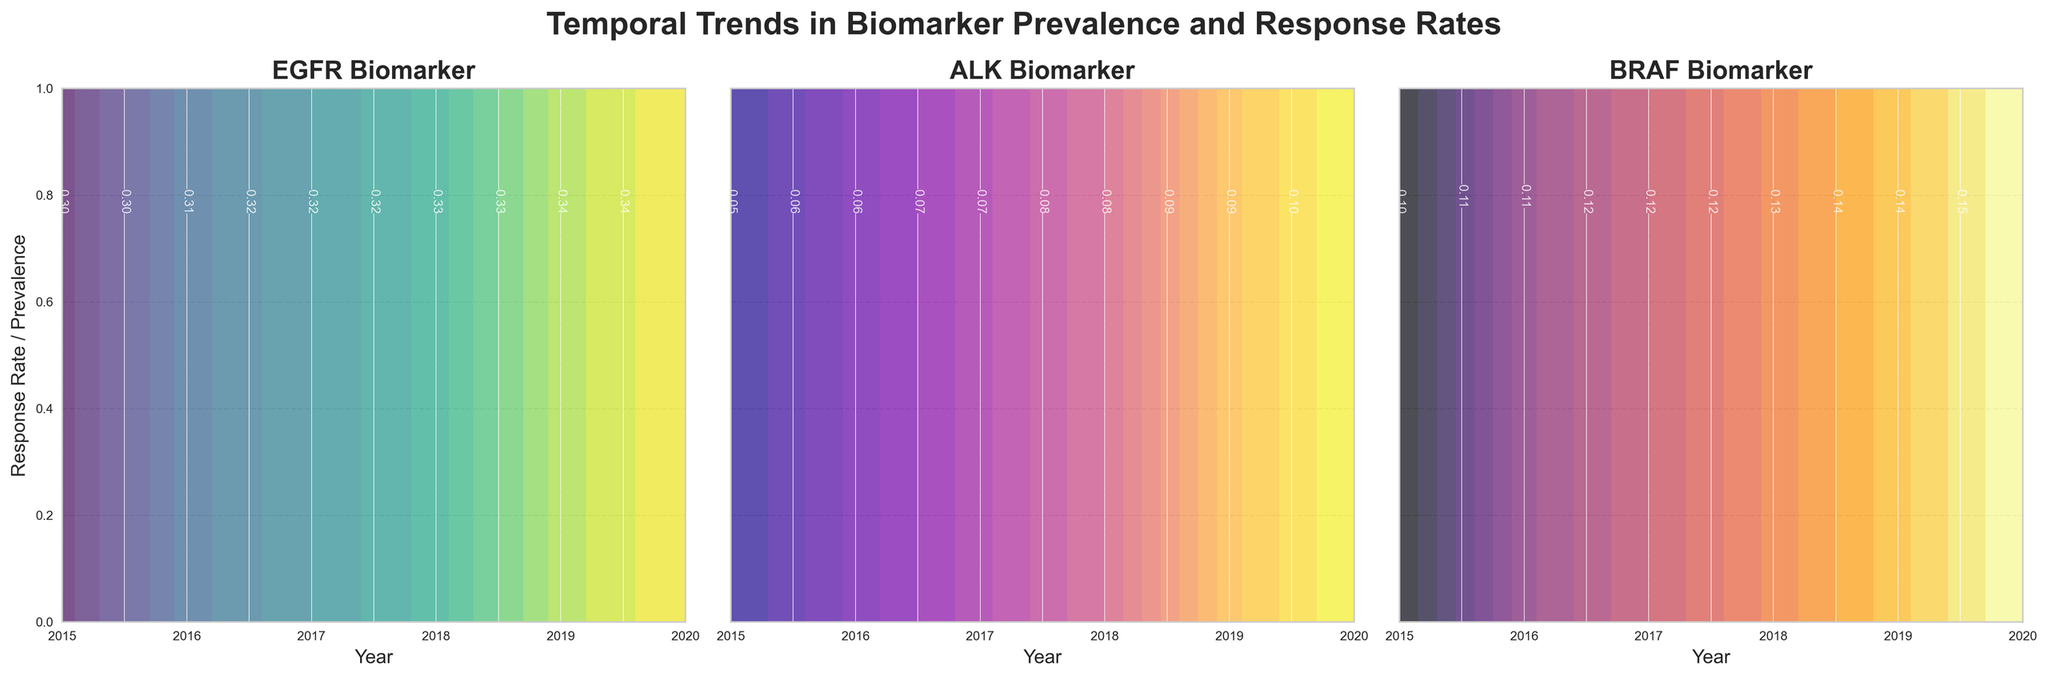What is the title of the figure? The title of the figure is displayed at the top of the plot, in bold font. It reads: "Temporal Trends in Biomarker Prevalence and Response Rates".
Answer: Temporal Trends in Biomarker Prevalence and Response Rates Which biomarker has the highest response rate in 2015? In the EGFR, ALK, and BRAF subplots, checking the contour values within the year 2015, ALK shows the highest response rate value.
Answer: ALK How do the EGFR and BRAF prevalence rates in 2019 compare? Examine the 2019 prevalence contours (white lines) in both the EGFR and BRAF subplots. The EGFR prevalence line is at a higher Y-value than BRAF, indicating a higher prevalence rate in 2019.
Answer: EGFR has a higher prevalence rate than BRAF in 2019 Which biomarker showed the most significant increase in prevalence from 2015 to 2020? Compare the contour lines' Y-axis values at 2015 and 2020 in each subplot. The difference between these values is most significant for BRAF, indicating the largest increase in prevalence.
Answer: BRAF What is the trend in the response rate of EGFR from 2015 to 2020? Look at the color gradation in the EGFR subplot from 2015 to 2020. The response rate shows a gradual increase, indicated by the shift to lighter colors towards 2020.
Answer: Increasing trend In 2020, which biomarker's response rate achieved a value of 0.51 as per the contour plot? Check the value within the contour plot for each biomarker in 2020. The ALK subplot shows a contour line meeting the value of 0.51 in 2020.
Answer: ALK How does the response rate of ALK in 2018 compare to that of BRAF in 2017? Compare the contour lines' value in ALK for 2018 and BRAF for 2017. ALK in 2018 has a response rate of approximately 0.48 whereas BRAF in 2017 is around 0.33.
Answer: ALK in 2018 is higher Which year does the EGFR prevalence first exceed 0.30? Identify the first contour line or label that exceeds the value of 0.30 on the Y-axis within the EGFR subplot. This occurs around 2016.
Answer: 2016 From 2015 to 2020, describe the trend in ALK prevalence. Following the white contour lines in the ALK subplot from 2015 to 2020, a steady upward trend is observed, indicating that ALK prevalence steadily increases over these years.
Answer: Steady increase Considering all biomarkers, in which year does the average response rate seem to be the highest? To find the average, consider the trends and contour values for each biomarker in the given years, 2019 shows an overall higher level for all biomarkers.
Answer: 2019 